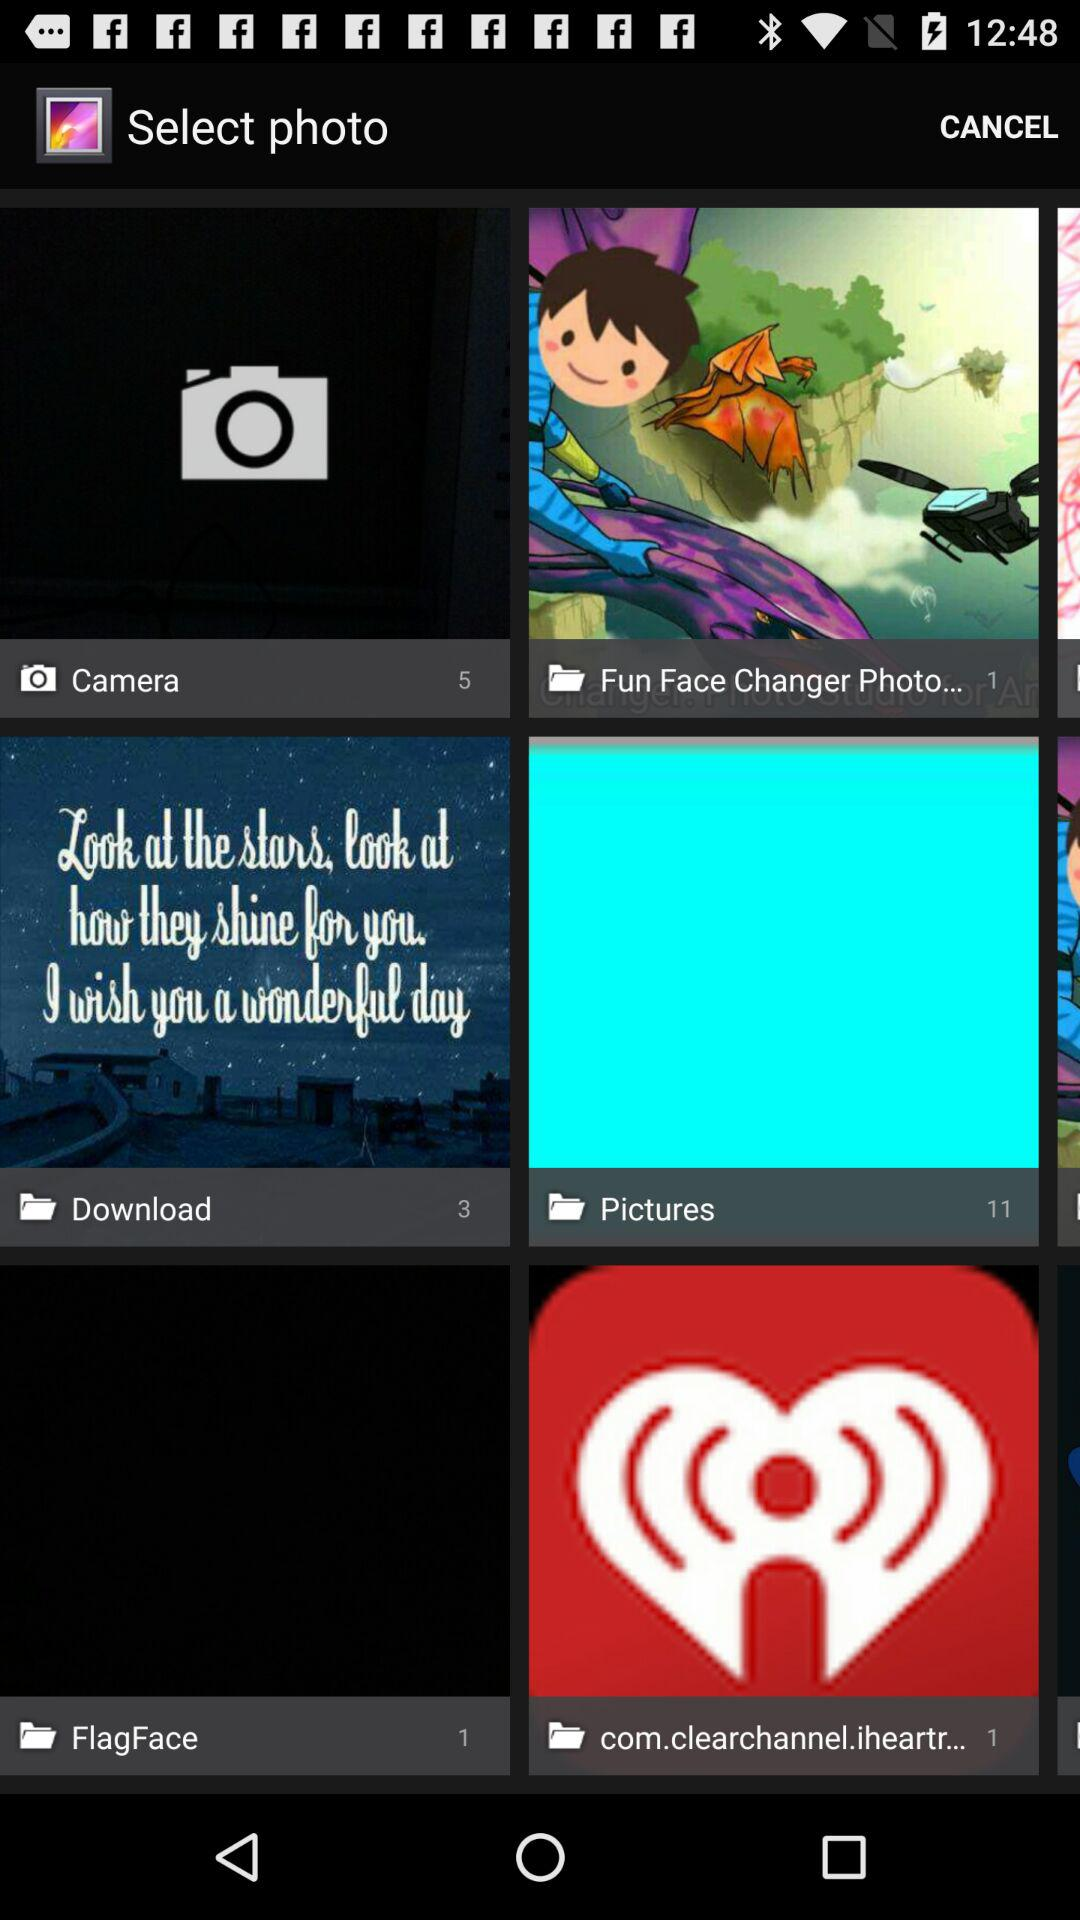How many pictures are in the "Pictures" folder? There are 11 pictures in the "Pictures" folder. 